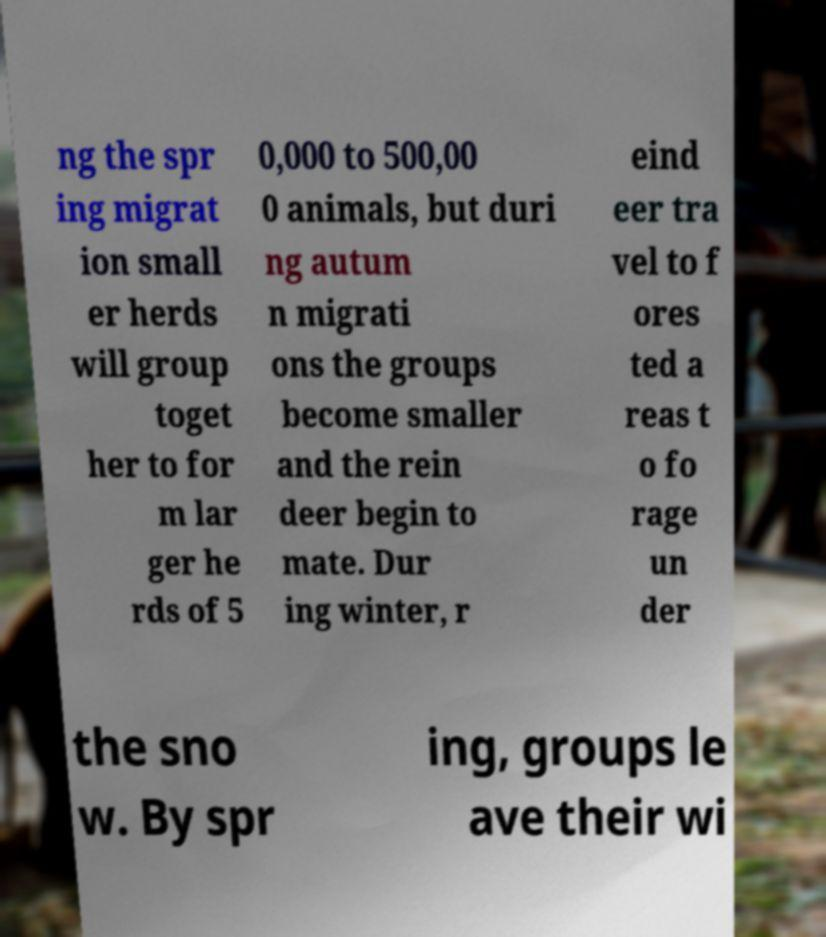Can you accurately transcribe the text from the provided image for me? ng the spr ing migrat ion small er herds will group toget her to for m lar ger he rds of 5 0,000 to 500,00 0 animals, but duri ng autum n migrati ons the groups become smaller and the rein deer begin to mate. Dur ing winter, r eind eer tra vel to f ores ted a reas t o fo rage un der the sno w. By spr ing, groups le ave their wi 